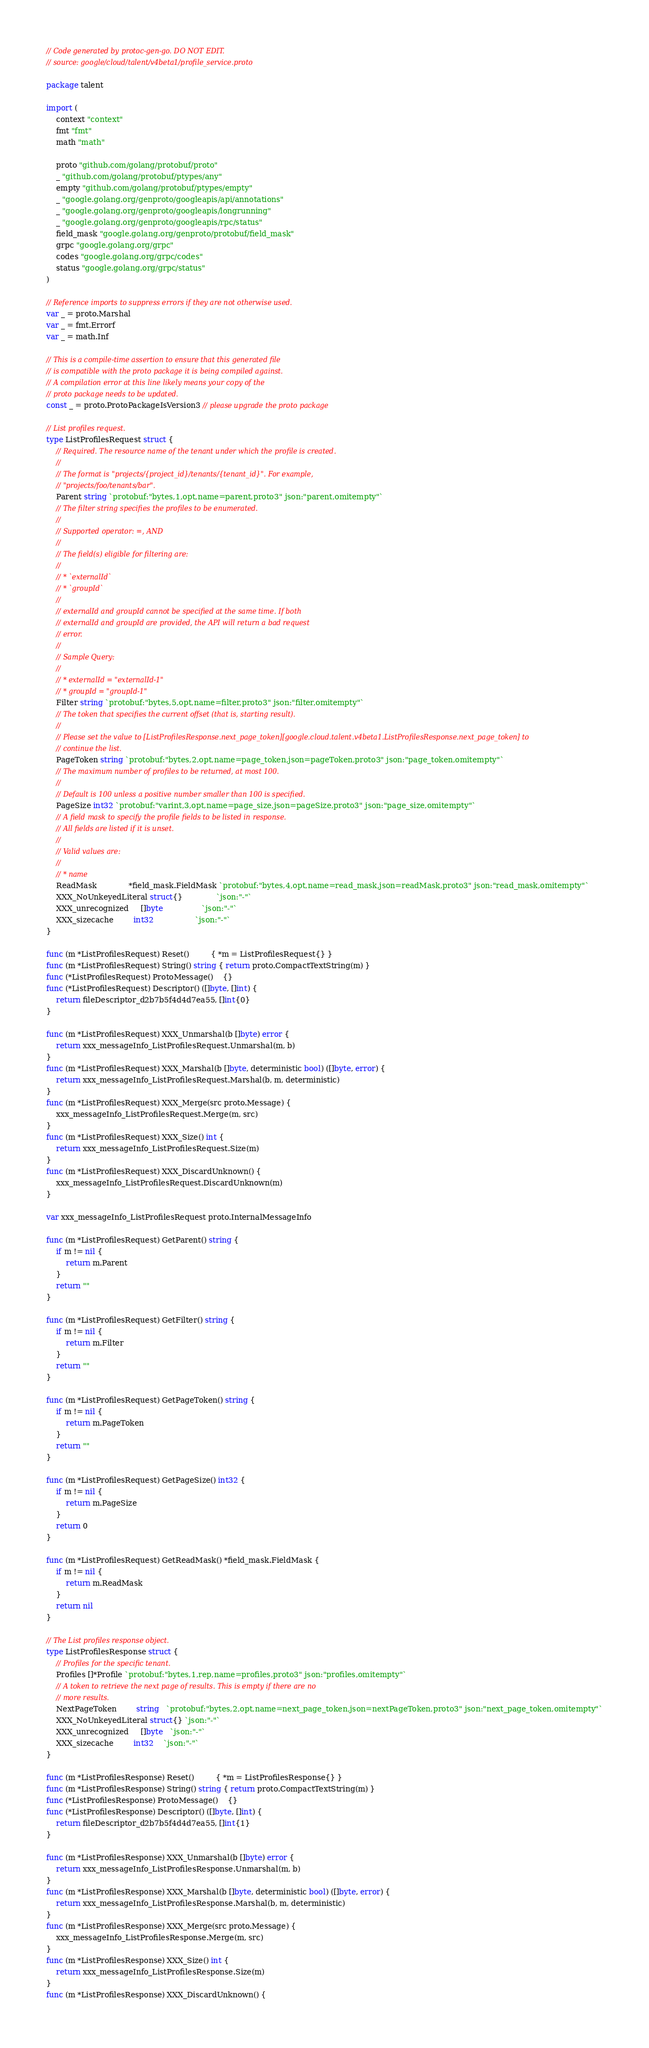Convert code to text. <code><loc_0><loc_0><loc_500><loc_500><_Go_>// Code generated by protoc-gen-go. DO NOT EDIT.
// source: google/cloud/talent/v4beta1/profile_service.proto

package talent

import (
	context "context"
	fmt "fmt"
	math "math"

	proto "github.com/golang/protobuf/proto"
	_ "github.com/golang/protobuf/ptypes/any"
	empty "github.com/golang/protobuf/ptypes/empty"
	_ "google.golang.org/genproto/googleapis/api/annotations"
	_ "google.golang.org/genproto/googleapis/longrunning"
	_ "google.golang.org/genproto/googleapis/rpc/status"
	field_mask "google.golang.org/genproto/protobuf/field_mask"
	grpc "google.golang.org/grpc"
	codes "google.golang.org/grpc/codes"
	status "google.golang.org/grpc/status"
)

// Reference imports to suppress errors if they are not otherwise used.
var _ = proto.Marshal
var _ = fmt.Errorf
var _ = math.Inf

// This is a compile-time assertion to ensure that this generated file
// is compatible with the proto package it is being compiled against.
// A compilation error at this line likely means your copy of the
// proto package needs to be updated.
const _ = proto.ProtoPackageIsVersion3 // please upgrade the proto package

// List profiles request.
type ListProfilesRequest struct {
	// Required. The resource name of the tenant under which the profile is created.
	//
	// The format is "projects/{project_id}/tenants/{tenant_id}". For example,
	// "projects/foo/tenants/bar".
	Parent string `protobuf:"bytes,1,opt,name=parent,proto3" json:"parent,omitempty"`
	// The filter string specifies the profiles to be enumerated.
	//
	// Supported operator: =, AND
	//
	// The field(s) eligible for filtering are:
	//
	// * `externalId`
	// * `groupId`
	//
	// externalId and groupId cannot be specified at the same time. If both
	// externalId and groupId are provided, the API will return a bad request
	// error.
	//
	// Sample Query:
	//
	// * externalId = "externalId-1"
	// * groupId = "groupId-1"
	Filter string `protobuf:"bytes,5,opt,name=filter,proto3" json:"filter,omitempty"`
	// The token that specifies the current offset (that is, starting result).
	//
	// Please set the value to [ListProfilesResponse.next_page_token][google.cloud.talent.v4beta1.ListProfilesResponse.next_page_token] to
	// continue the list.
	PageToken string `protobuf:"bytes,2,opt,name=page_token,json=pageToken,proto3" json:"page_token,omitempty"`
	// The maximum number of profiles to be returned, at most 100.
	//
	// Default is 100 unless a positive number smaller than 100 is specified.
	PageSize int32 `protobuf:"varint,3,opt,name=page_size,json=pageSize,proto3" json:"page_size,omitempty"`
	// A field mask to specify the profile fields to be listed in response.
	// All fields are listed if it is unset.
	//
	// Valid values are:
	//
	// * name
	ReadMask             *field_mask.FieldMask `protobuf:"bytes,4,opt,name=read_mask,json=readMask,proto3" json:"read_mask,omitempty"`
	XXX_NoUnkeyedLiteral struct{}              `json:"-"`
	XXX_unrecognized     []byte                `json:"-"`
	XXX_sizecache        int32                 `json:"-"`
}

func (m *ListProfilesRequest) Reset()         { *m = ListProfilesRequest{} }
func (m *ListProfilesRequest) String() string { return proto.CompactTextString(m) }
func (*ListProfilesRequest) ProtoMessage()    {}
func (*ListProfilesRequest) Descriptor() ([]byte, []int) {
	return fileDescriptor_d2b7b5f4d4d7ea55, []int{0}
}

func (m *ListProfilesRequest) XXX_Unmarshal(b []byte) error {
	return xxx_messageInfo_ListProfilesRequest.Unmarshal(m, b)
}
func (m *ListProfilesRequest) XXX_Marshal(b []byte, deterministic bool) ([]byte, error) {
	return xxx_messageInfo_ListProfilesRequest.Marshal(b, m, deterministic)
}
func (m *ListProfilesRequest) XXX_Merge(src proto.Message) {
	xxx_messageInfo_ListProfilesRequest.Merge(m, src)
}
func (m *ListProfilesRequest) XXX_Size() int {
	return xxx_messageInfo_ListProfilesRequest.Size(m)
}
func (m *ListProfilesRequest) XXX_DiscardUnknown() {
	xxx_messageInfo_ListProfilesRequest.DiscardUnknown(m)
}

var xxx_messageInfo_ListProfilesRequest proto.InternalMessageInfo

func (m *ListProfilesRequest) GetParent() string {
	if m != nil {
		return m.Parent
	}
	return ""
}

func (m *ListProfilesRequest) GetFilter() string {
	if m != nil {
		return m.Filter
	}
	return ""
}

func (m *ListProfilesRequest) GetPageToken() string {
	if m != nil {
		return m.PageToken
	}
	return ""
}

func (m *ListProfilesRequest) GetPageSize() int32 {
	if m != nil {
		return m.PageSize
	}
	return 0
}

func (m *ListProfilesRequest) GetReadMask() *field_mask.FieldMask {
	if m != nil {
		return m.ReadMask
	}
	return nil
}

// The List profiles response object.
type ListProfilesResponse struct {
	// Profiles for the specific tenant.
	Profiles []*Profile `protobuf:"bytes,1,rep,name=profiles,proto3" json:"profiles,omitempty"`
	// A token to retrieve the next page of results. This is empty if there are no
	// more results.
	NextPageToken        string   `protobuf:"bytes,2,opt,name=next_page_token,json=nextPageToken,proto3" json:"next_page_token,omitempty"`
	XXX_NoUnkeyedLiteral struct{} `json:"-"`
	XXX_unrecognized     []byte   `json:"-"`
	XXX_sizecache        int32    `json:"-"`
}

func (m *ListProfilesResponse) Reset()         { *m = ListProfilesResponse{} }
func (m *ListProfilesResponse) String() string { return proto.CompactTextString(m) }
func (*ListProfilesResponse) ProtoMessage()    {}
func (*ListProfilesResponse) Descriptor() ([]byte, []int) {
	return fileDescriptor_d2b7b5f4d4d7ea55, []int{1}
}

func (m *ListProfilesResponse) XXX_Unmarshal(b []byte) error {
	return xxx_messageInfo_ListProfilesResponse.Unmarshal(m, b)
}
func (m *ListProfilesResponse) XXX_Marshal(b []byte, deterministic bool) ([]byte, error) {
	return xxx_messageInfo_ListProfilesResponse.Marshal(b, m, deterministic)
}
func (m *ListProfilesResponse) XXX_Merge(src proto.Message) {
	xxx_messageInfo_ListProfilesResponse.Merge(m, src)
}
func (m *ListProfilesResponse) XXX_Size() int {
	return xxx_messageInfo_ListProfilesResponse.Size(m)
}
func (m *ListProfilesResponse) XXX_DiscardUnknown() {</code> 